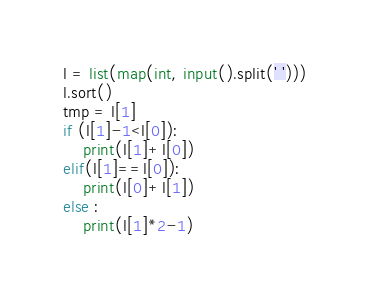<code> <loc_0><loc_0><loc_500><loc_500><_Python_>l = list(map(int, input().split(' ')))
l.sort()
tmp = l[1]
if (l[1]-1<l[0]):
    print(l[1]+l[0])
elif(l[1]==l[0]):
    print(l[0]+l[1])
else :
    print(l[1]*2-1)
</code> 